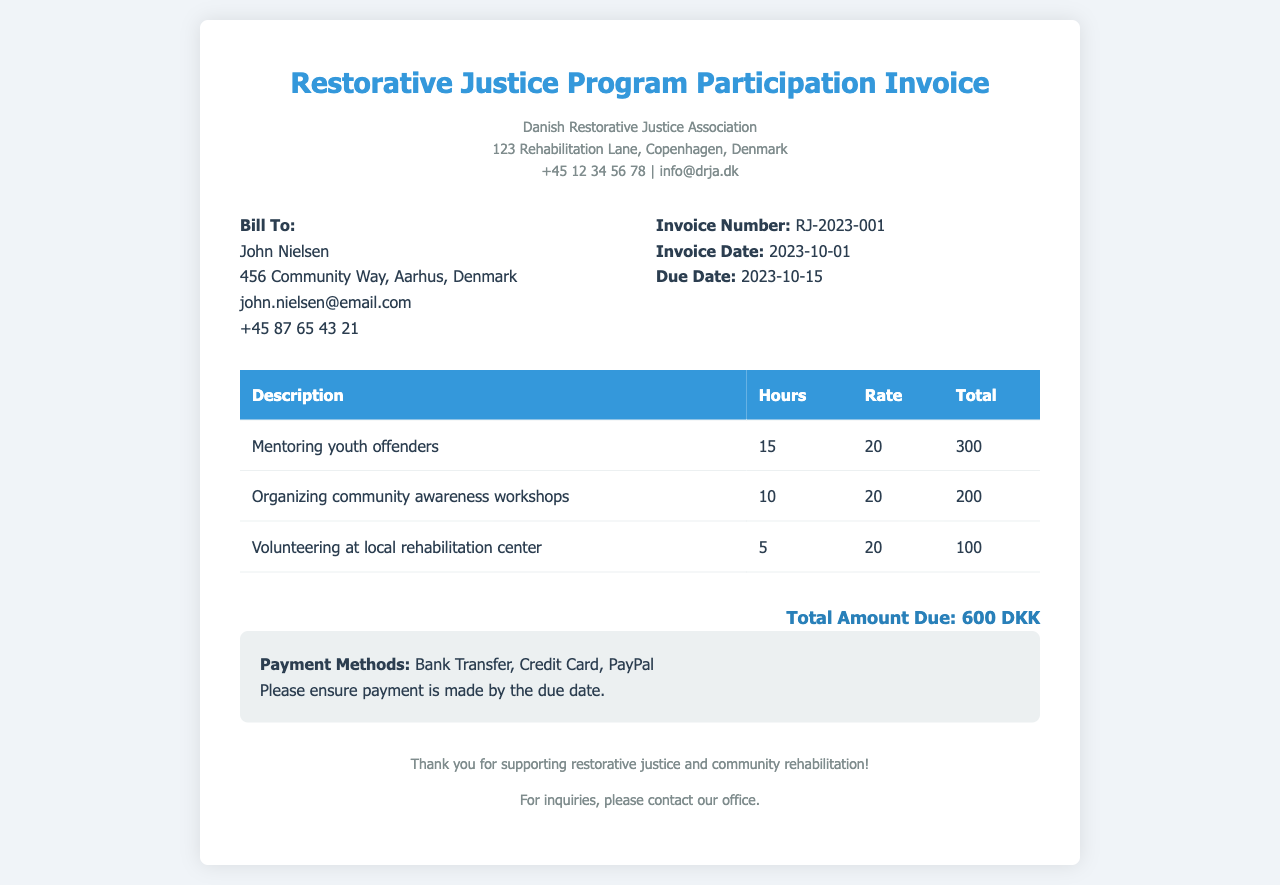what is the invoice number? The invoice number is listed in the document under invoice details.
Answer: RJ-2023-001 who is the bill recipient? The bill recipient is mentioned in the "Bill To" section of the document.
Answer: John Nielsen what is the total amount due? The total amount due is specified at the bottom of the invoice.
Answer: 600 DKK when is the invoice date? The invoice date is found in the invoice details section.
Answer: 2023-10-01 how many hours were dedicated to mentoring youth offenders? The hours dedicated to mentoring youth offenders are specified in the table of services rendered.
Answer: 15 what is the rate for the community service hours? The rate for community service hours is the same for each activity, as shown in the table.
Answer: 20 what is the due date for payment? The due date for payment can be found in the invoice details section.
Answer: 2023-10-15 what activities are included in the invoice? The activities listed in the invoice can be found in the table under descriptions.
Answer: Mentoring youth offenders, Organizing community awareness workshops, Volunteering at local rehabilitation center what payment methods are accepted? The accepted payment methods are mentioned in the payment information section of the invoice.
Answer: Bank Transfer, Credit Card, PayPal 